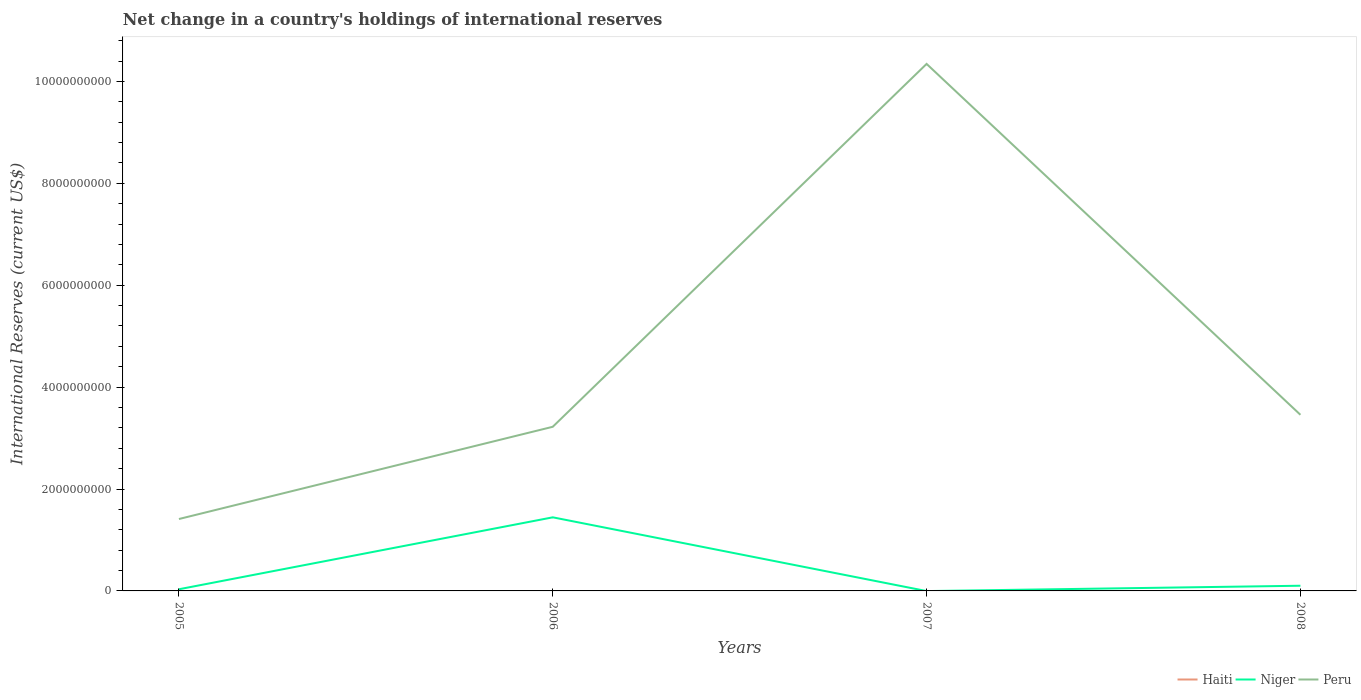Does the line corresponding to Peru intersect with the line corresponding to Niger?
Provide a succinct answer. No. Is the number of lines equal to the number of legend labels?
Make the answer very short. No. Across all years, what is the maximum international reserves in Peru?
Provide a short and direct response. 1.41e+09. What is the total international reserves in Niger in the graph?
Offer a very short reply. -6.90e+07. What is the difference between the highest and the second highest international reserves in Niger?
Your answer should be compact. 1.44e+09. How many years are there in the graph?
Give a very brief answer. 4. Does the graph contain any zero values?
Provide a short and direct response. Yes. Does the graph contain grids?
Your response must be concise. No. Where does the legend appear in the graph?
Your answer should be compact. Bottom right. What is the title of the graph?
Ensure brevity in your answer.  Net change in a country's holdings of international reserves. What is the label or title of the Y-axis?
Your answer should be very brief. International Reserves (current US$). What is the International Reserves (current US$) of Niger in 2005?
Offer a very short reply. 3.28e+07. What is the International Reserves (current US$) in Peru in 2005?
Provide a short and direct response. 1.41e+09. What is the International Reserves (current US$) in Haiti in 2006?
Provide a short and direct response. 0. What is the International Reserves (current US$) of Niger in 2006?
Ensure brevity in your answer.  1.44e+09. What is the International Reserves (current US$) of Peru in 2006?
Make the answer very short. 3.22e+09. What is the International Reserves (current US$) in Haiti in 2007?
Make the answer very short. 0. What is the International Reserves (current US$) of Niger in 2007?
Your answer should be very brief. 0. What is the International Reserves (current US$) in Peru in 2007?
Provide a succinct answer. 1.03e+1. What is the International Reserves (current US$) in Niger in 2008?
Your response must be concise. 1.02e+08. What is the International Reserves (current US$) of Peru in 2008?
Offer a terse response. 3.46e+09. Across all years, what is the maximum International Reserves (current US$) in Niger?
Give a very brief answer. 1.44e+09. Across all years, what is the maximum International Reserves (current US$) of Peru?
Provide a succinct answer. 1.03e+1. Across all years, what is the minimum International Reserves (current US$) of Niger?
Keep it short and to the point. 0. Across all years, what is the minimum International Reserves (current US$) of Peru?
Provide a short and direct response. 1.41e+09. What is the total International Reserves (current US$) in Niger in the graph?
Provide a short and direct response. 1.58e+09. What is the total International Reserves (current US$) in Peru in the graph?
Make the answer very short. 1.84e+1. What is the difference between the International Reserves (current US$) of Niger in 2005 and that in 2006?
Your response must be concise. -1.41e+09. What is the difference between the International Reserves (current US$) of Peru in 2005 and that in 2006?
Your answer should be compact. -1.81e+09. What is the difference between the International Reserves (current US$) of Peru in 2005 and that in 2007?
Your response must be concise. -8.93e+09. What is the difference between the International Reserves (current US$) of Niger in 2005 and that in 2008?
Make the answer very short. -6.90e+07. What is the difference between the International Reserves (current US$) of Peru in 2005 and that in 2008?
Keep it short and to the point. -2.05e+09. What is the difference between the International Reserves (current US$) of Peru in 2006 and that in 2007?
Your answer should be very brief. -7.12e+09. What is the difference between the International Reserves (current US$) of Niger in 2006 and that in 2008?
Ensure brevity in your answer.  1.34e+09. What is the difference between the International Reserves (current US$) in Peru in 2006 and that in 2008?
Offer a very short reply. -2.35e+08. What is the difference between the International Reserves (current US$) of Peru in 2007 and that in 2008?
Your response must be concise. 6.89e+09. What is the difference between the International Reserves (current US$) in Niger in 2005 and the International Reserves (current US$) in Peru in 2006?
Ensure brevity in your answer.  -3.19e+09. What is the difference between the International Reserves (current US$) in Niger in 2005 and the International Reserves (current US$) in Peru in 2007?
Offer a very short reply. -1.03e+1. What is the difference between the International Reserves (current US$) in Niger in 2005 and the International Reserves (current US$) in Peru in 2008?
Offer a terse response. -3.42e+09. What is the difference between the International Reserves (current US$) in Niger in 2006 and the International Reserves (current US$) in Peru in 2007?
Give a very brief answer. -8.90e+09. What is the difference between the International Reserves (current US$) in Niger in 2006 and the International Reserves (current US$) in Peru in 2008?
Give a very brief answer. -2.01e+09. What is the average International Reserves (current US$) in Haiti per year?
Make the answer very short. 0. What is the average International Reserves (current US$) of Niger per year?
Provide a succinct answer. 3.95e+08. What is the average International Reserves (current US$) of Peru per year?
Offer a very short reply. 4.61e+09. In the year 2005, what is the difference between the International Reserves (current US$) of Niger and International Reserves (current US$) of Peru?
Provide a succinct answer. -1.38e+09. In the year 2006, what is the difference between the International Reserves (current US$) of Niger and International Reserves (current US$) of Peru?
Your answer should be very brief. -1.78e+09. In the year 2008, what is the difference between the International Reserves (current US$) of Niger and International Reserves (current US$) of Peru?
Make the answer very short. -3.35e+09. What is the ratio of the International Reserves (current US$) of Niger in 2005 to that in 2006?
Ensure brevity in your answer.  0.02. What is the ratio of the International Reserves (current US$) in Peru in 2005 to that in 2006?
Offer a terse response. 0.44. What is the ratio of the International Reserves (current US$) in Peru in 2005 to that in 2007?
Provide a succinct answer. 0.14. What is the ratio of the International Reserves (current US$) of Niger in 2005 to that in 2008?
Your answer should be compact. 0.32. What is the ratio of the International Reserves (current US$) in Peru in 2005 to that in 2008?
Ensure brevity in your answer.  0.41. What is the ratio of the International Reserves (current US$) of Peru in 2006 to that in 2007?
Your answer should be very brief. 0.31. What is the ratio of the International Reserves (current US$) of Niger in 2006 to that in 2008?
Ensure brevity in your answer.  14.18. What is the ratio of the International Reserves (current US$) in Peru in 2006 to that in 2008?
Provide a succinct answer. 0.93. What is the ratio of the International Reserves (current US$) of Peru in 2007 to that in 2008?
Provide a succinct answer. 2.99. What is the difference between the highest and the second highest International Reserves (current US$) of Niger?
Your answer should be very brief. 1.34e+09. What is the difference between the highest and the second highest International Reserves (current US$) in Peru?
Offer a terse response. 6.89e+09. What is the difference between the highest and the lowest International Reserves (current US$) in Niger?
Provide a short and direct response. 1.44e+09. What is the difference between the highest and the lowest International Reserves (current US$) of Peru?
Your answer should be very brief. 8.93e+09. 